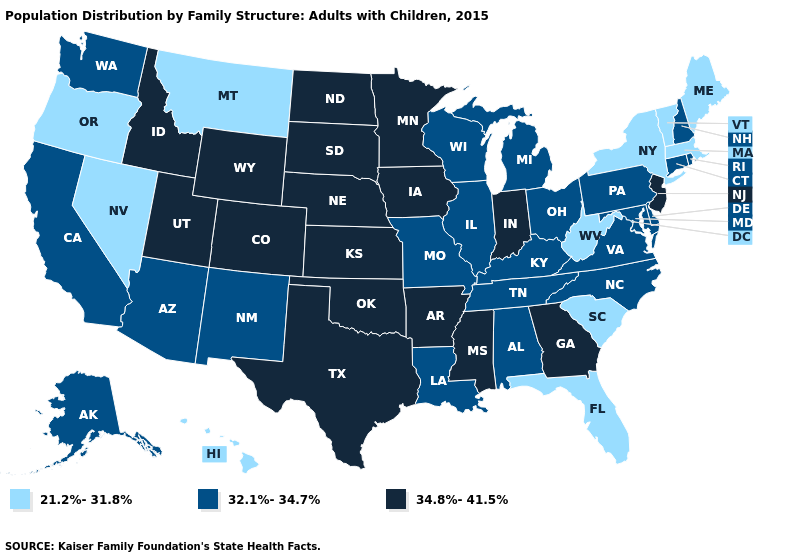Name the states that have a value in the range 34.8%-41.5%?
Short answer required. Arkansas, Colorado, Georgia, Idaho, Indiana, Iowa, Kansas, Minnesota, Mississippi, Nebraska, New Jersey, North Dakota, Oklahoma, South Dakota, Texas, Utah, Wyoming. Name the states that have a value in the range 32.1%-34.7%?
Short answer required. Alabama, Alaska, Arizona, California, Connecticut, Delaware, Illinois, Kentucky, Louisiana, Maryland, Michigan, Missouri, New Hampshire, New Mexico, North Carolina, Ohio, Pennsylvania, Rhode Island, Tennessee, Virginia, Washington, Wisconsin. What is the highest value in the South ?
Keep it brief. 34.8%-41.5%. What is the value of Maryland?
Concise answer only. 32.1%-34.7%. Among the states that border Illinois , which have the highest value?
Concise answer only. Indiana, Iowa. What is the lowest value in states that border Illinois?
Be succinct. 32.1%-34.7%. Among the states that border Ohio , does Pennsylvania have the lowest value?
Short answer required. No. Is the legend a continuous bar?
Answer briefly. No. How many symbols are there in the legend?
Concise answer only. 3. What is the value of Kentucky?
Concise answer only. 32.1%-34.7%. What is the highest value in the USA?
Write a very short answer. 34.8%-41.5%. Among the states that border Nevada , which have the lowest value?
Write a very short answer. Oregon. Name the states that have a value in the range 32.1%-34.7%?
Quick response, please. Alabama, Alaska, Arizona, California, Connecticut, Delaware, Illinois, Kentucky, Louisiana, Maryland, Michigan, Missouri, New Hampshire, New Mexico, North Carolina, Ohio, Pennsylvania, Rhode Island, Tennessee, Virginia, Washington, Wisconsin. Does Michigan have the lowest value in the MidWest?
Keep it brief. Yes. What is the lowest value in the MidWest?
Answer briefly. 32.1%-34.7%. 